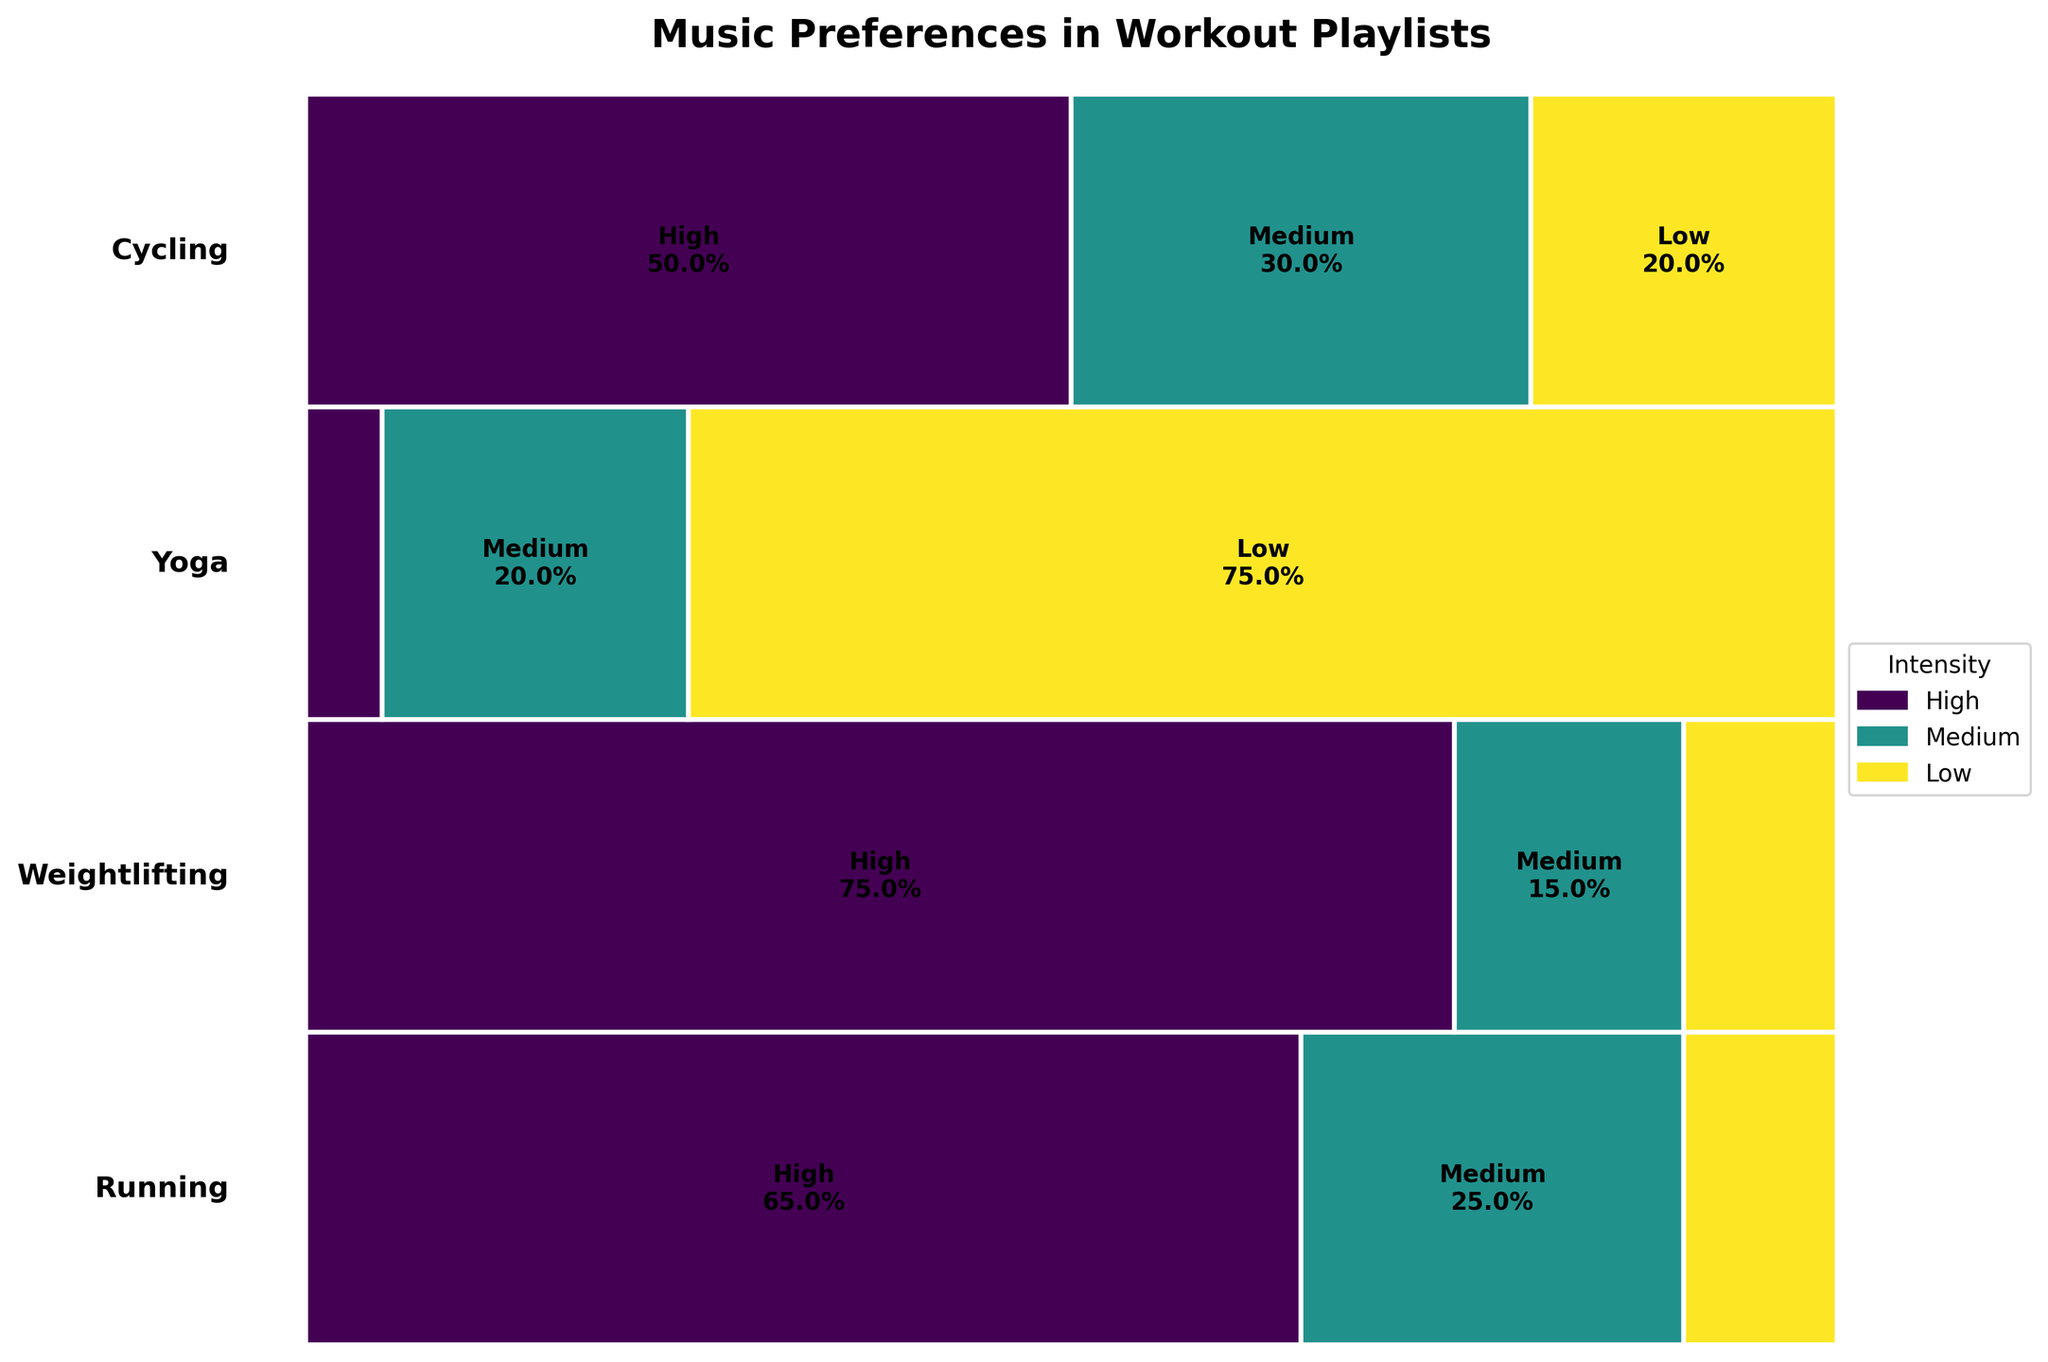What is the title of the plot? The title is usually located at the top of the plot, centered and in large font. In this plot, the title states clearly the focus of the visual representation.
Answer: Music Preferences in Workout Playlists Which exercise type has the highest proportion in the plot? By observing the vertical allocation of space in the plot, the exercise type that occupies the largest area vertically represents the highest proportion.
Answer: Yoga Which intensity level is most common for weightlifting? For weightlifting, we look at the weightlifting rectangles and identify which color-intensity combination is most dominant.
Answer: High How does the proportion of high intensity in yoga compare to running? Evaluate the width of the high-intensity rectangles for both yoga and running by comparing their relative sizes directly.
Answer: Smaller in yoga What genre is most associated with cycling at medium intensity? Walk through all proportions for cycling at medium intensity, paying attention to rectangle widths and any possible annotations or labels that specify genres.
Answer: Pop What percentage of the total data does low-intensity yoga represent? Calculate the percentage by determining the total vertical space occupied by low-intensity yoga relative to the entire plot. Refer to the data values if necessary.
Answer: 10.2% Which genre appears for high intensity in weightlifting, and how frequent is it? Identify the genre by inspecting the high-intensity rectangle for weightlifting and reading any labels or annotations within that segment.
Answer: Metal, 40 If you sum up all frequencies of high-intensity workouts, how many do they account for? Add the individual frequencies listed for high-intensity across all exercise types, ensuring complete inclusion.
Answer: 170 In terms of workout intensity, which exercise type has the least variety? Examine which exercise type has fewer intensity levels represented by the different colored rectangles.
Answer: Yoga Is there any type of exercise that completely lacks low intensity? Look for any exercise type that does not have a rectangle corresponding to the low-intensity color in the plot.
Answer: Weightlifting 